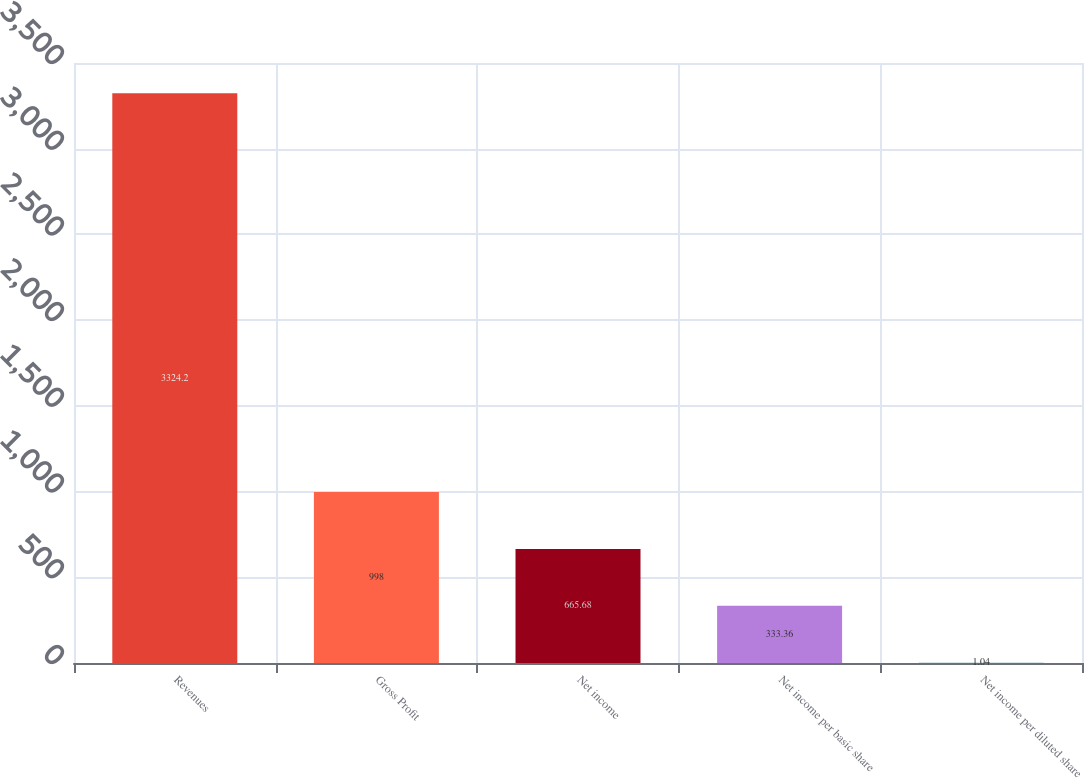Convert chart. <chart><loc_0><loc_0><loc_500><loc_500><bar_chart><fcel>Revenues<fcel>Gross Profit<fcel>Net income<fcel>Net income per basic share<fcel>Net income per diluted share<nl><fcel>3324.2<fcel>998<fcel>665.68<fcel>333.36<fcel>1.04<nl></chart> 